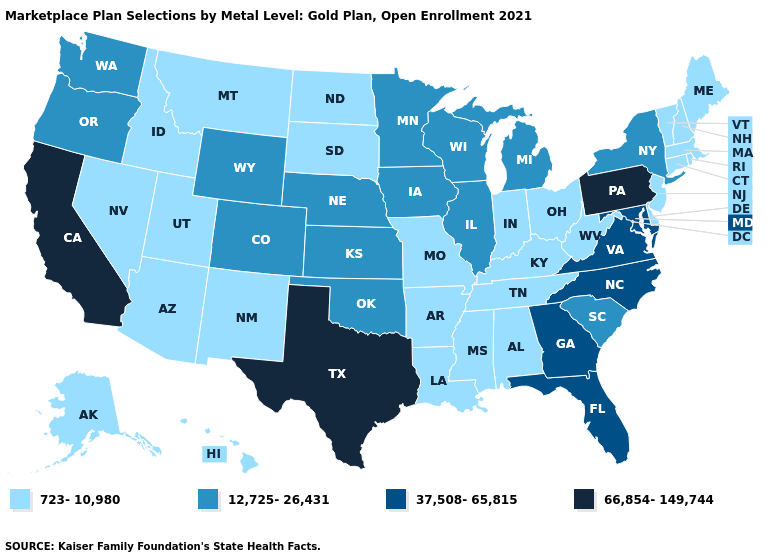Name the states that have a value in the range 37,508-65,815?
Quick response, please. Florida, Georgia, Maryland, North Carolina, Virginia. Which states hav the highest value in the South?
Be succinct. Texas. Does Alabama have the same value as Illinois?
Be succinct. No. Name the states that have a value in the range 12,725-26,431?
Write a very short answer. Colorado, Illinois, Iowa, Kansas, Michigan, Minnesota, Nebraska, New York, Oklahoma, Oregon, South Carolina, Washington, Wisconsin, Wyoming. Does Florida have a higher value than Pennsylvania?
Short answer required. No. Which states hav the highest value in the West?
Quick response, please. California. Is the legend a continuous bar?
Answer briefly. No. Does South Dakota have the lowest value in the MidWest?
Quick response, please. Yes. Which states have the lowest value in the USA?
Short answer required. Alabama, Alaska, Arizona, Arkansas, Connecticut, Delaware, Hawaii, Idaho, Indiana, Kentucky, Louisiana, Maine, Massachusetts, Mississippi, Missouri, Montana, Nevada, New Hampshire, New Jersey, New Mexico, North Dakota, Ohio, Rhode Island, South Dakota, Tennessee, Utah, Vermont, West Virginia. Does California have the highest value in the USA?
Quick response, please. Yes. What is the value of Oklahoma?
Keep it brief. 12,725-26,431. Does Georgia have the same value as Minnesota?
Write a very short answer. No. Name the states that have a value in the range 66,854-149,744?
Keep it brief. California, Pennsylvania, Texas. What is the value of North Carolina?
Keep it brief. 37,508-65,815. Does the map have missing data?
Be succinct. No. 